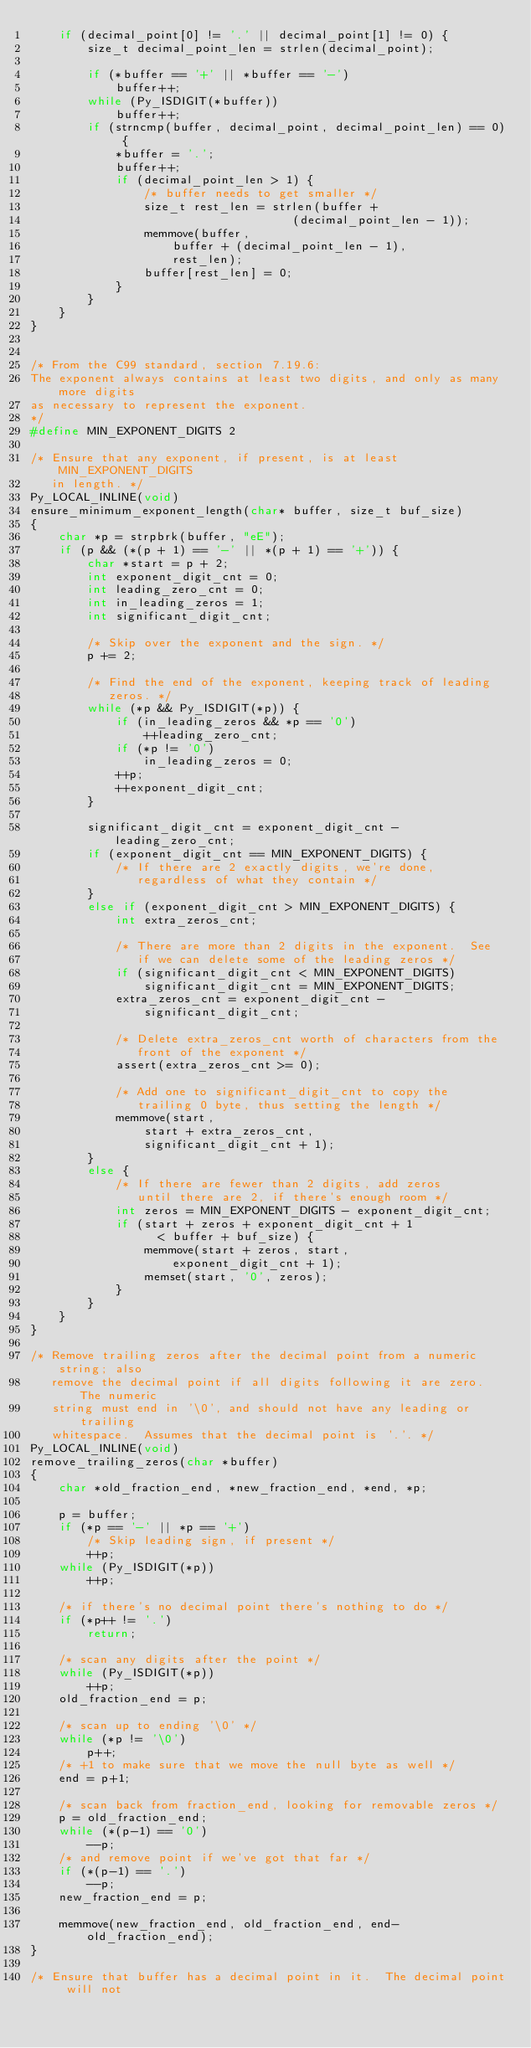<code> <loc_0><loc_0><loc_500><loc_500><_C_>    if (decimal_point[0] != '.' || decimal_point[1] != 0) {
        size_t decimal_point_len = strlen(decimal_point);

        if (*buffer == '+' || *buffer == '-')
            buffer++;
        while (Py_ISDIGIT(*buffer))
            buffer++;
        if (strncmp(buffer, decimal_point, decimal_point_len) == 0) {
            *buffer = '.';
            buffer++;
            if (decimal_point_len > 1) {
                /* buffer needs to get smaller */
                size_t rest_len = strlen(buffer +
                                     (decimal_point_len - 1));
                memmove(buffer,
                    buffer + (decimal_point_len - 1),
                    rest_len);
                buffer[rest_len] = 0;
            }
        }
    }
}


/* From the C99 standard, section 7.19.6:
The exponent always contains at least two digits, and only as many more digits
as necessary to represent the exponent.
*/
#define MIN_EXPONENT_DIGITS 2

/* Ensure that any exponent, if present, is at least MIN_EXPONENT_DIGITS
   in length. */
Py_LOCAL_INLINE(void)
ensure_minimum_exponent_length(char* buffer, size_t buf_size)
{
    char *p = strpbrk(buffer, "eE");
    if (p && (*(p + 1) == '-' || *(p + 1) == '+')) {
        char *start = p + 2;
        int exponent_digit_cnt = 0;
        int leading_zero_cnt = 0;
        int in_leading_zeros = 1;
        int significant_digit_cnt;

        /* Skip over the exponent and the sign. */
        p += 2;

        /* Find the end of the exponent, keeping track of leading
           zeros. */
        while (*p && Py_ISDIGIT(*p)) {
            if (in_leading_zeros && *p == '0')
                ++leading_zero_cnt;
            if (*p != '0')
                in_leading_zeros = 0;
            ++p;
            ++exponent_digit_cnt;
        }

        significant_digit_cnt = exponent_digit_cnt - leading_zero_cnt;
        if (exponent_digit_cnt == MIN_EXPONENT_DIGITS) {
            /* If there are 2 exactly digits, we're done,
               regardless of what they contain */
        }
        else if (exponent_digit_cnt > MIN_EXPONENT_DIGITS) {
            int extra_zeros_cnt;

            /* There are more than 2 digits in the exponent.  See
               if we can delete some of the leading zeros */
            if (significant_digit_cnt < MIN_EXPONENT_DIGITS)
                significant_digit_cnt = MIN_EXPONENT_DIGITS;
            extra_zeros_cnt = exponent_digit_cnt -
                significant_digit_cnt;

            /* Delete extra_zeros_cnt worth of characters from the
               front of the exponent */
            assert(extra_zeros_cnt >= 0);

            /* Add one to significant_digit_cnt to copy the
               trailing 0 byte, thus setting the length */
            memmove(start,
                start + extra_zeros_cnt,
                significant_digit_cnt + 1);
        }
        else {
            /* If there are fewer than 2 digits, add zeros
               until there are 2, if there's enough room */
            int zeros = MIN_EXPONENT_DIGITS - exponent_digit_cnt;
            if (start + zeros + exponent_digit_cnt + 1
                  < buffer + buf_size) {
                memmove(start + zeros, start,
                    exponent_digit_cnt + 1);
                memset(start, '0', zeros);
            }
        }
    }
}

/* Remove trailing zeros after the decimal point from a numeric string; also
   remove the decimal point if all digits following it are zero.  The numeric
   string must end in '\0', and should not have any leading or trailing
   whitespace.  Assumes that the decimal point is '.'. */
Py_LOCAL_INLINE(void)
remove_trailing_zeros(char *buffer)
{
    char *old_fraction_end, *new_fraction_end, *end, *p;

    p = buffer;
    if (*p == '-' || *p == '+')
        /* Skip leading sign, if present */
        ++p;
    while (Py_ISDIGIT(*p))
        ++p;

    /* if there's no decimal point there's nothing to do */
    if (*p++ != '.')
        return;

    /* scan any digits after the point */
    while (Py_ISDIGIT(*p))
        ++p;
    old_fraction_end = p;

    /* scan up to ending '\0' */
    while (*p != '\0')
        p++;
    /* +1 to make sure that we move the null byte as well */
    end = p+1;

    /* scan back from fraction_end, looking for removable zeros */
    p = old_fraction_end;
    while (*(p-1) == '0')
        --p;
    /* and remove point if we've got that far */
    if (*(p-1) == '.')
        --p;
    new_fraction_end = p;

    memmove(new_fraction_end, old_fraction_end, end-old_fraction_end);
}

/* Ensure that buffer has a decimal point in it.  The decimal point will not</code> 